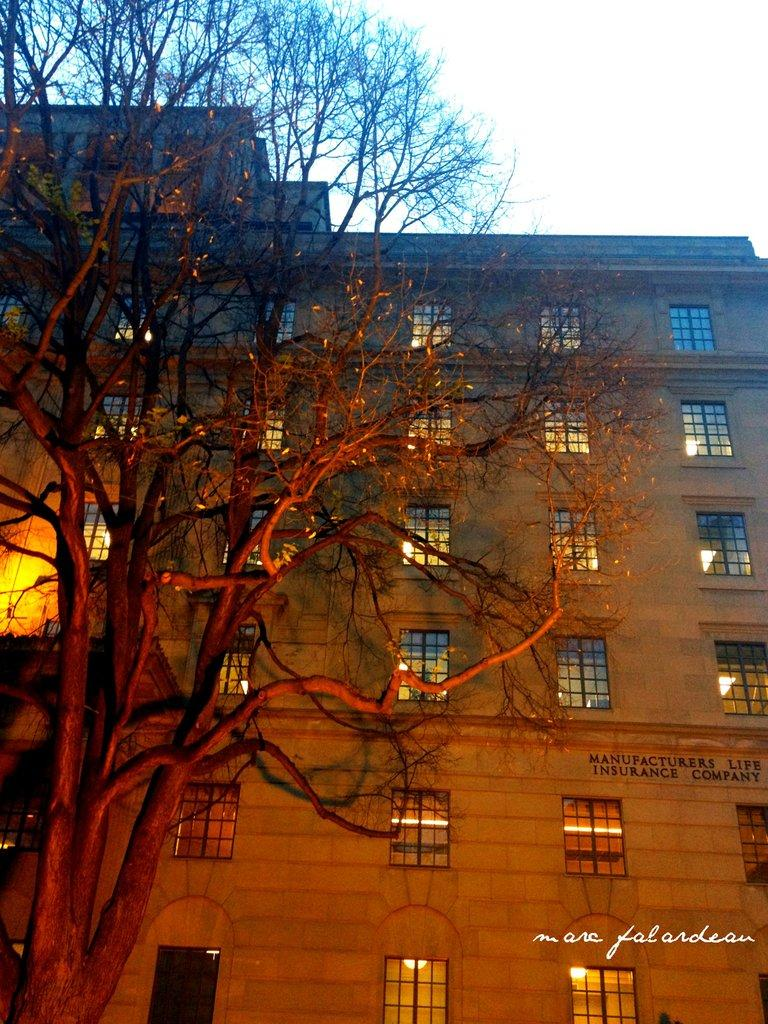What type of structure is present in the image? There is a building in the image. What can be seen on the ground in the image? There is a tree with no leaves in the image. What is visible in the background of the image? The sky is visible in the background of the image. What type of nut is being used to enforce the rule in the image? There is no nut or rule present in the image; it only features a building and a tree with no leaves. 